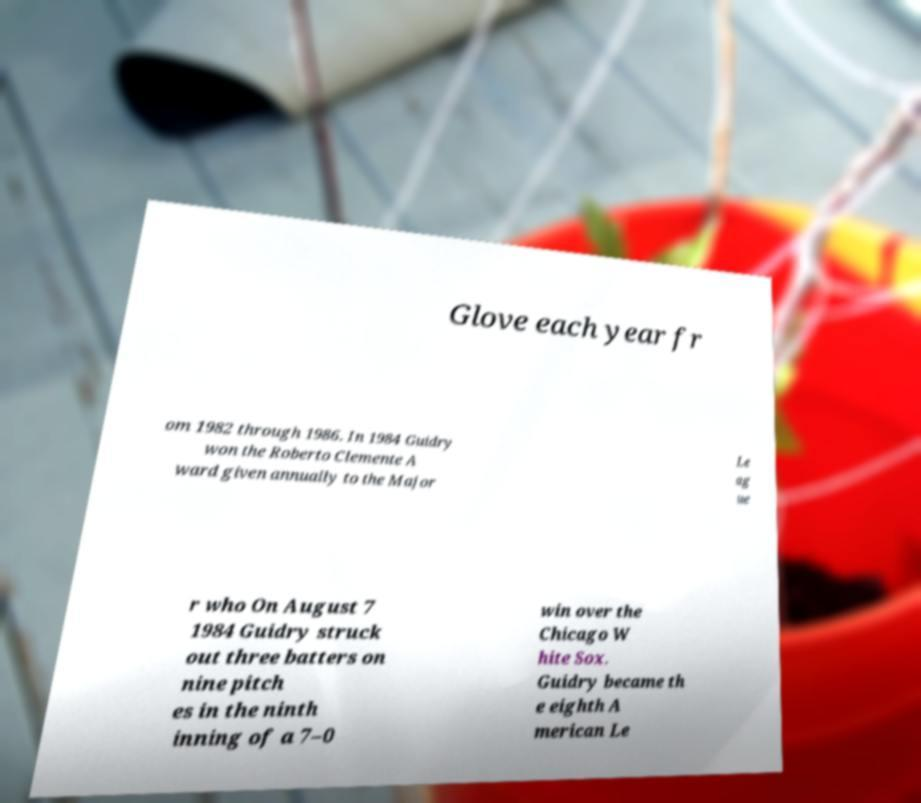I need the written content from this picture converted into text. Can you do that? Glove each year fr om 1982 through 1986. In 1984 Guidry won the Roberto Clemente A ward given annually to the Major Le ag ue r who On August 7 1984 Guidry struck out three batters on nine pitch es in the ninth inning of a 7–0 win over the Chicago W hite Sox. Guidry became th e eighth A merican Le 